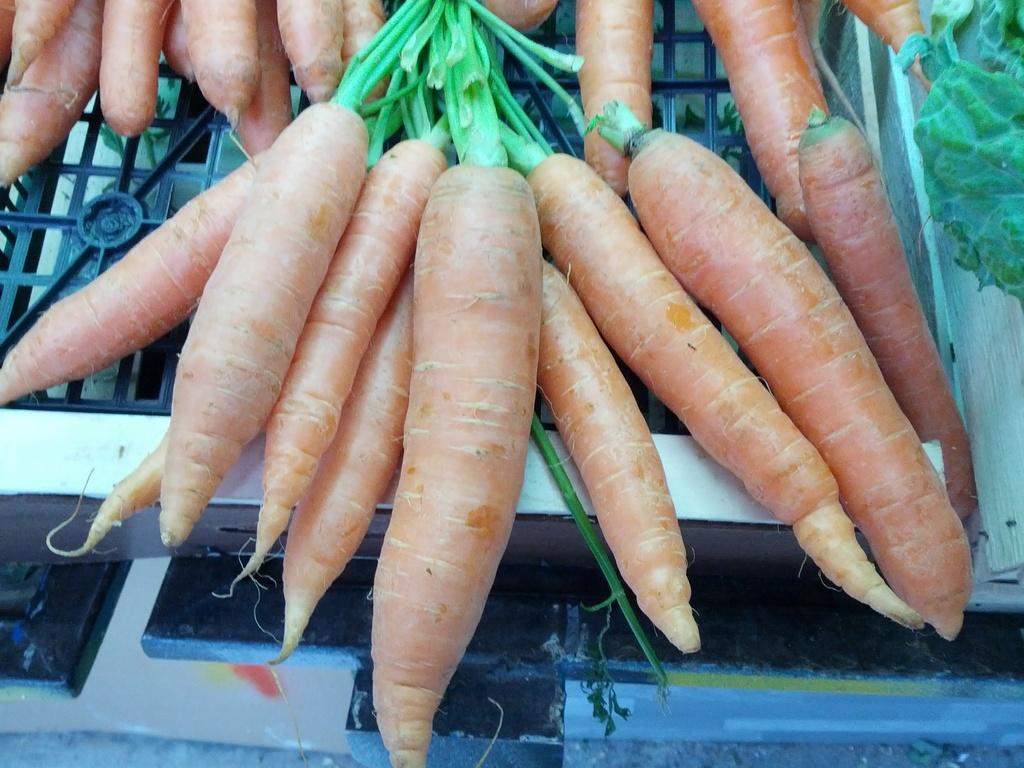Can you describe this image briefly? In this picture I can see many carrots which are kept on the box. Beside that I can see some green chili which is kept on the white cotton box. At the it might be the water. 